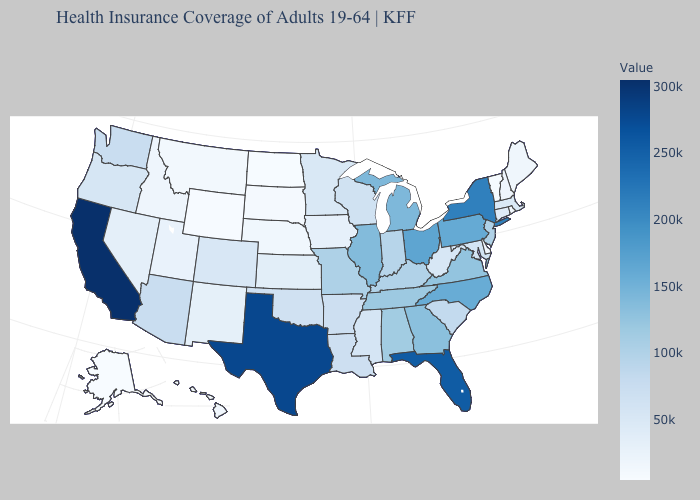Which states hav the highest value in the Northeast?
Keep it brief. New York. Which states hav the highest value in the South?
Keep it brief. Texas. Does the map have missing data?
Answer briefly. No. Which states have the lowest value in the Northeast?
Quick response, please. Vermont. 